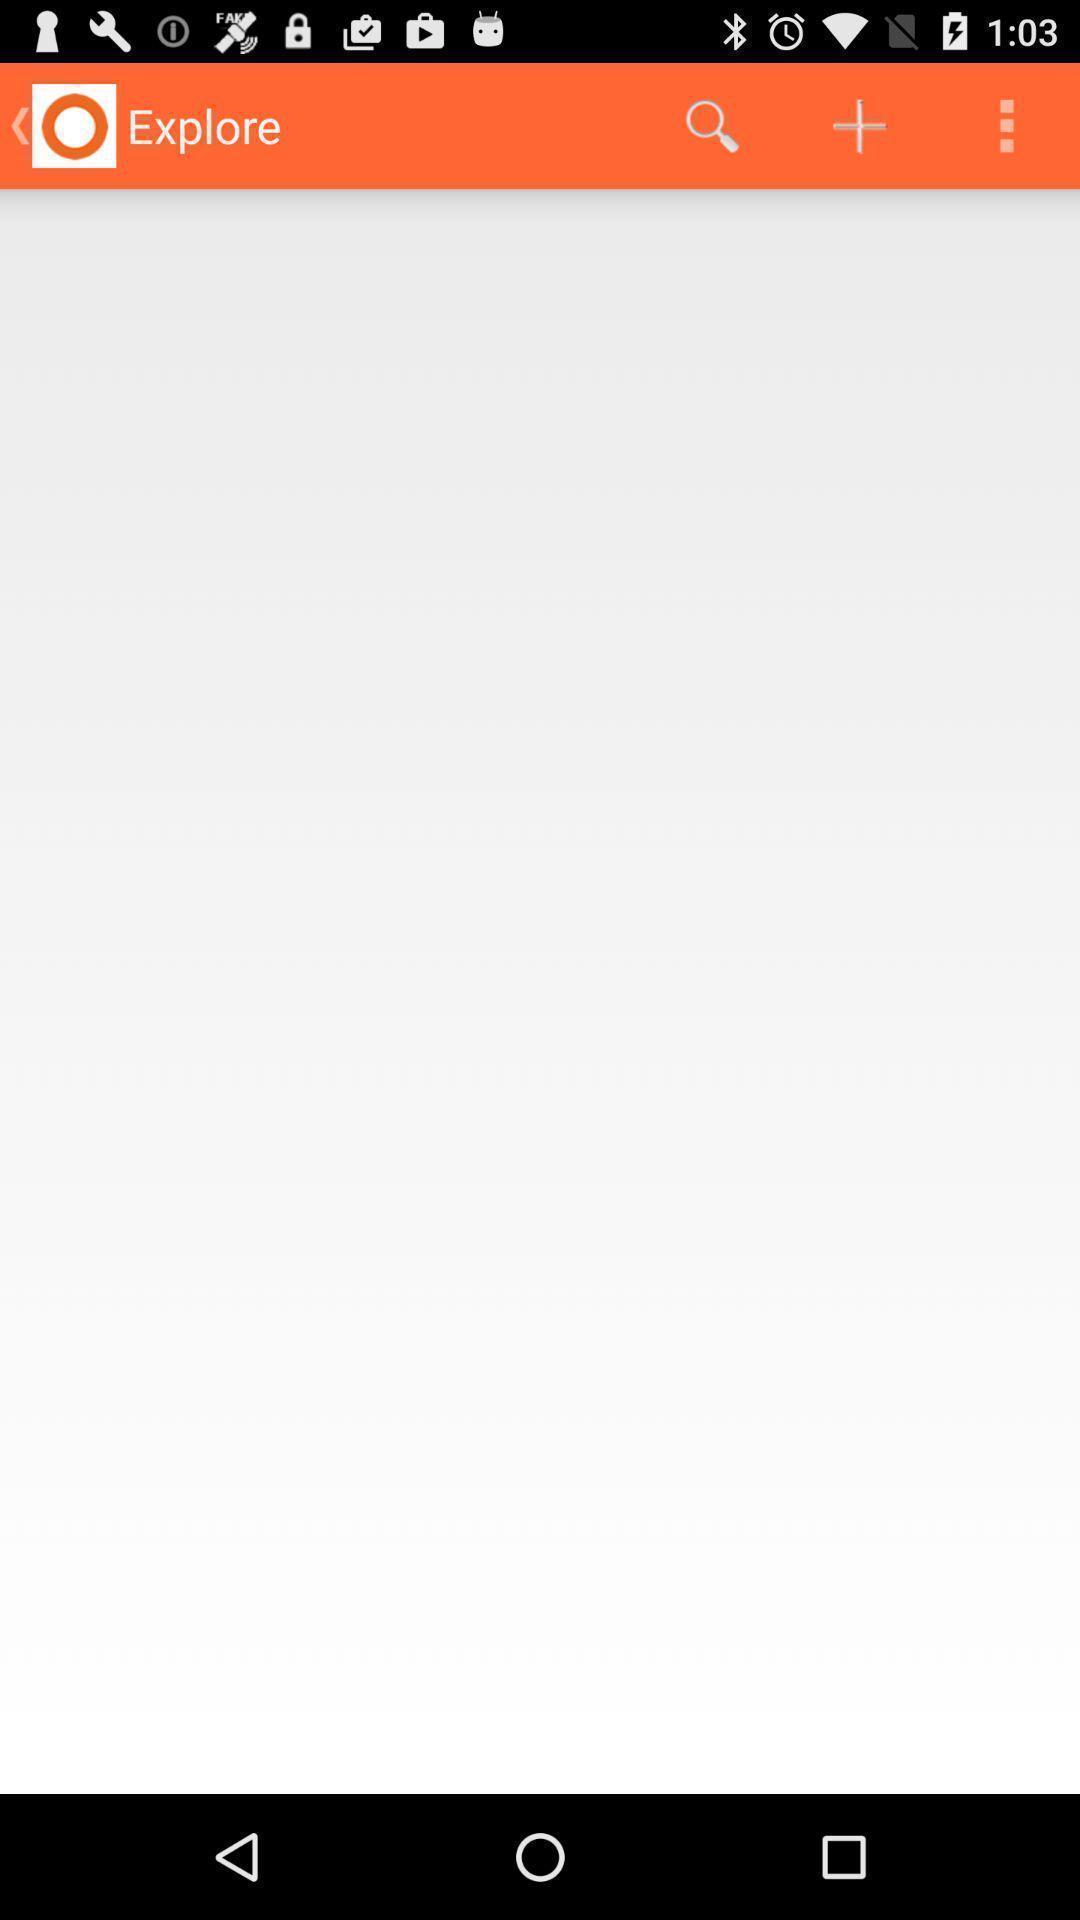Explain what's happening in this screen capture. Page showing of different options in application. 